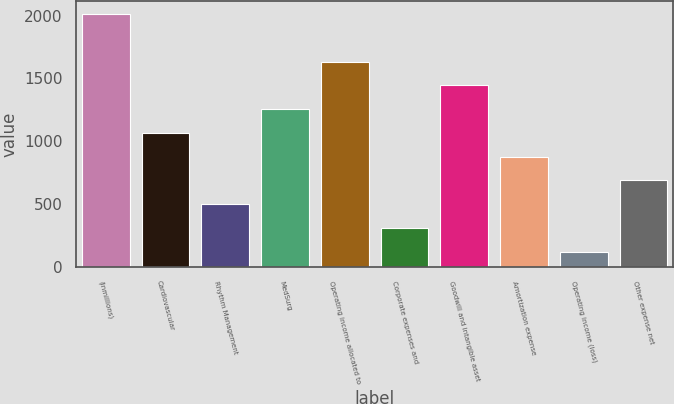Convert chart to OTSL. <chart><loc_0><loc_0><loc_500><loc_500><bar_chart><fcel>(inmillions)<fcel>Cardiovascular<fcel>Rhythm Management<fcel>MedSurg<fcel>Operating income allocated to<fcel>Corporate expenses and<fcel>Goodwill and intangible asset<fcel>Amortization expense<fcel>Operating income (loss)<fcel>Other expense net<nl><fcel>2013<fcel>1066.5<fcel>498.6<fcel>1255.8<fcel>1634.4<fcel>309.3<fcel>1445.1<fcel>877.2<fcel>120<fcel>687.9<nl></chart> 